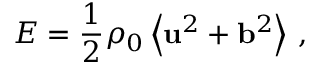Convert formula to latex. <formula><loc_0><loc_0><loc_500><loc_500>E = \frac { 1 } { 2 } \rho _ { 0 } \left \langle { u } ^ { 2 } + { b } ^ { 2 } \right \rangle \, ,</formula> 